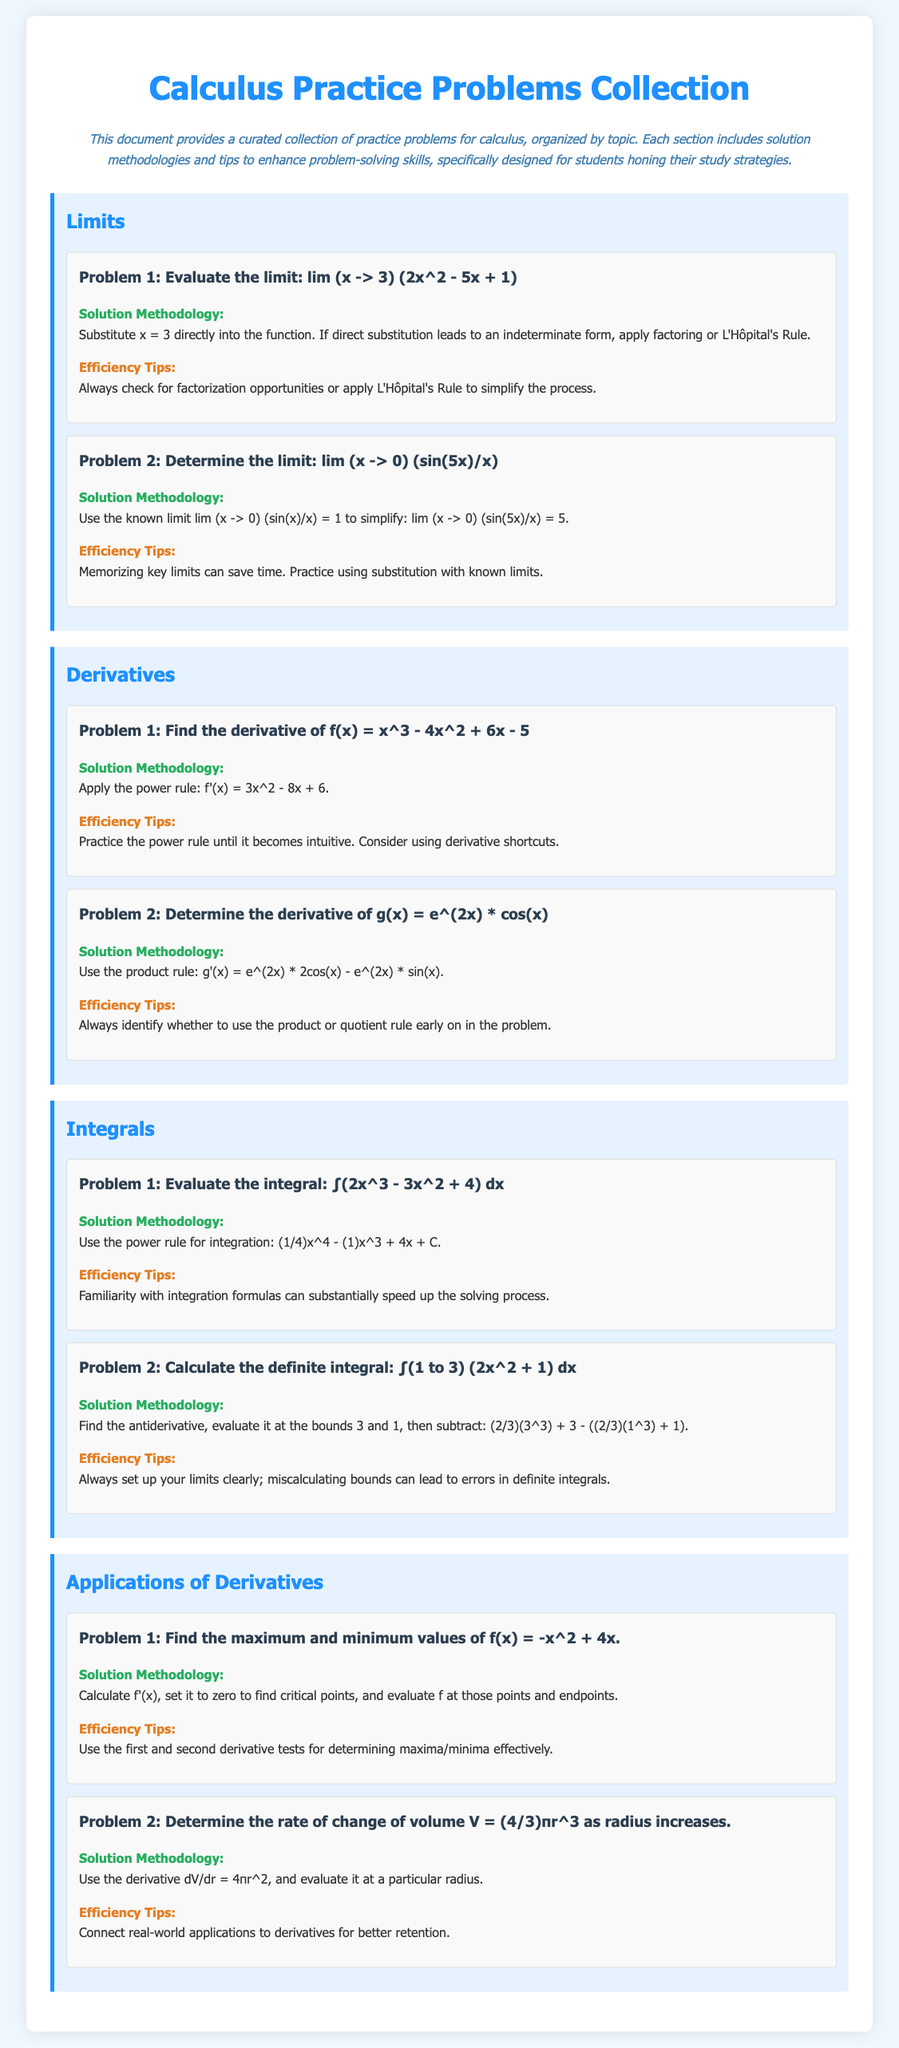What are the two topics covered under Derivatives? The topics covered under Derivatives are finding the derivative of a function and determining the derivative using the product rule.
Answer: f(x) and g(x) What is the methodology for evaluating the limit lim (x -> 0) (sin(5x)/x)? The methodology involves using the known limit lim (x -> 0) (sin(x)/x) = 1 to simplify the expression.
Answer: Simplify to 5 What is the title of the document? The title of the document is found in the header section, presenting the main subject of the collection.
Answer: Calculus Practice Problems Collection Which efficiency tips are provided for solving integrals? The tips suggest that familiarity with integration formulas can speed up the solving process.
Answer: Familiarity with integration formulas What is the maximum value of the function f(x) = -x^2 + 4x? To find the maximum value, you calculate the critical points and evaluate the function at those points.
Answer: 8 